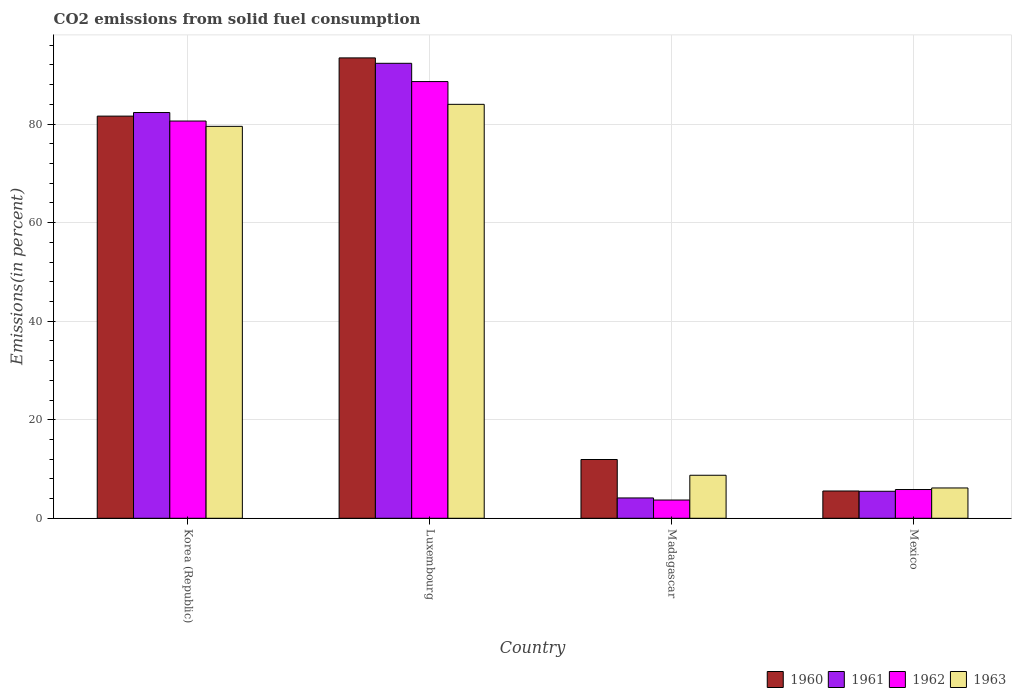How many groups of bars are there?
Provide a short and direct response. 4. How many bars are there on the 2nd tick from the left?
Offer a terse response. 4. What is the label of the 2nd group of bars from the left?
Your answer should be very brief. Luxembourg. In how many cases, is the number of bars for a given country not equal to the number of legend labels?
Your answer should be compact. 0. What is the total CO2 emitted in 1963 in Madagascar?
Offer a very short reply. 8.73. Across all countries, what is the maximum total CO2 emitted in 1962?
Provide a short and direct response. 88.63. Across all countries, what is the minimum total CO2 emitted in 1963?
Make the answer very short. 6.15. In which country was the total CO2 emitted in 1962 maximum?
Provide a short and direct response. Luxembourg. In which country was the total CO2 emitted in 1962 minimum?
Offer a very short reply. Madagascar. What is the total total CO2 emitted in 1960 in the graph?
Keep it short and to the point. 192.53. What is the difference between the total CO2 emitted in 1961 in Korea (Republic) and that in Luxembourg?
Offer a very short reply. -9.99. What is the difference between the total CO2 emitted in 1963 in Madagascar and the total CO2 emitted in 1962 in Korea (Republic)?
Your answer should be very brief. -71.89. What is the average total CO2 emitted in 1961 per country?
Provide a short and direct response. 46.08. What is the difference between the total CO2 emitted of/in 1962 and total CO2 emitted of/in 1961 in Luxembourg?
Give a very brief answer. -3.71. What is the ratio of the total CO2 emitted in 1962 in Luxembourg to that in Mexico?
Offer a very short reply. 15.2. Is the total CO2 emitted in 1963 in Madagascar less than that in Mexico?
Provide a succinct answer. No. Is the difference between the total CO2 emitted in 1962 in Madagascar and Mexico greater than the difference between the total CO2 emitted in 1961 in Madagascar and Mexico?
Offer a very short reply. No. What is the difference between the highest and the second highest total CO2 emitted in 1963?
Keep it short and to the point. -75.29. What is the difference between the highest and the lowest total CO2 emitted in 1960?
Offer a very short reply. 87.9. What does the 2nd bar from the right in Luxembourg represents?
Offer a very short reply. 1962. Are all the bars in the graph horizontal?
Offer a very short reply. No. What is the difference between two consecutive major ticks on the Y-axis?
Provide a succinct answer. 20. Are the values on the major ticks of Y-axis written in scientific E-notation?
Offer a terse response. No. Does the graph contain any zero values?
Your answer should be very brief. No. Does the graph contain grids?
Ensure brevity in your answer.  Yes. Where does the legend appear in the graph?
Provide a short and direct response. Bottom right. How are the legend labels stacked?
Your answer should be compact. Horizontal. What is the title of the graph?
Your answer should be compact. CO2 emissions from solid fuel consumption. Does "1988" appear as one of the legend labels in the graph?
Keep it short and to the point. No. What is the label or title of the X-axis?
Provide a short and direct response. Country. What is the label or title of the Y-axis?
Ensure brevity in your answer.  Emissions(in percent). What is the Emissions(in percent) of 1960 in Korea (Republic)?
Provide a short and direct response. 81.62. What is the Emissions(in percent) of 1961 in Korea (Republic)?
Make the answer very short. 82.35. What is the Emissions(in percent) in 1962 in Korea (Republic)?
Ensure brevity in your answer.  80.62. What is the Emissions(in percent) of 1963 in Korea (Republic)?
Offer a very short reply. 79.55. What is the Emissions(in percent) of 1960 in Luxembourg?
Ensure brevity in your answer.  93.44. What is the Emissions(in percent) of 1961 in Luxembourg?
Your answer should be very brief. 92.34. What is the Emissions(in percent) of 1962 in Luxembourg?
Ensure brevity in your answer.  88.63. What is the Emissions(in percent) in 1963 in Luxembourg?
Your response must be concise. 84.02. What is the Emissions(in percent) in 1960 in Madagascar?
Offer a very short reply. 11.93. What is the Emissions(in percent) in 1961 in Madagascar?
Offer a terse response. 4.12. What is the Emissions(in percent) in 1962 in Madagascar?
Give a very brief answer. 3.7. What is the Emissions(in percent) in 1963 in Madagascar?
Offer a very short reply. 8.73. What is the Emissions(in percent) of 1960 in Mexico?
Provide a succinct answer. 5.54. What is the Emissions(in percent) in 1961 in Mexico?
Keep it short and to the point. 5.48. What is the Emissions(in percent) in 1962 in Mexico?
Your answer should be very brief. 5.83. What is the Emissions(in percent) of 1963 in Mexico?
Provide a succinct answer. 6.15. Across all countries, what is the maximum Emissions(in percent) of 1960?
Your answer should be compact. 93.44. Across all countries, what is the maximum Emissions(in percent) in 1961?
Provide a succinct answer. 92.34. Across all countries, what is the maximum Emissions(in percent) in 1962?
Offer a terse response. 88.63. Across all countries, what is the maximum Emissions(in percent) in 1963?
Your response must be concise. 84.02. Across all countries, what is the minimum Emissions(in percent) in 1960?
Keep it short and to the point. 5.54. Across all countries, what is the minimum Emissions(in percent) in 1961?
Make the answer very short. 4.12. Across all countries, what is the minimum Emissions(in percent) of 1962?
Your answer should be compact. 3.7. Across all countries, what is the minimum Emissions(in percent) in 1963?
Your answer should be very brief. 6.15. What is the total Emissions(in percent) in 1960 in the graph?
Give a very brief answer. 192.53. What is the total Emissions(in percent) of 1961 in the graph?
Give a very brief answer. 184.3. What is the total Emissions(in percent) in 1962 in the graph?
Keep it short and to the point. 178.8. What is the total Emissions(in percent) in 1963 in the graph?
Keep it short and to the point. 178.45. What is the difference between the Emissions(in percent) of 1960 in Korea (Republic) and that in Luxembourg?
Provide a short and direct response. -11.82. What is the difference between the Emissions(in percent) in 1961 in Korea (Republic) and that in Luxembourg?
Ensure brevity in your answer.  -9.99. What is the difference between the Emissions(in percent) in 1962 in Korea (Republic) and that in Luxembourg?
Give a very brief answer. -8.01. What is the difference between the Emissions(in percent) of 1963 in Korea (Republic) and that in Luxembourg?
Your response must be concise. -4.47. What is the difference between the Emissions(in percent) of 1960 in Korea (Republic) and that in Madagascar?
Your answer should be compact. 69.7. What is the difference between the Emissions(in percent) in 1961 in Korea (Republic) and that in Madagascar?
Keep it short and to the point. 78.23. What is the difference between the Emissions(in percent) in 1962 in Korea (Republic) and that in Madagascar?
Your answer should be very brief. 76.92. What is the difference between the Emissions(in percent) of 1963 in Korea (Republic) and that in Madagascar?
Ensure brevity in your answer.  70.82. What is the difference between the Emissions(in percent) of 1960 in Korea (Republic) and that in Mexico?
Your response must be concise. 76.09. What is the difference between the Emissions(in percent) in 1961 in Korea (Republic) and that in Mexico?
Provide a short and direct response. 76.87. What is the difference between the Emissions(in percent) of 1962 in Korea (Republic) and that in Mexico?
Provide a succinct answer. 74.79. What is the difference between the Emissions(in percent) of 1963 in Korea (Republic) and that in Mexico?
Make the answer very short. 73.4. What is the difference between the Emissions(in percent) of 1960 in Luxembourg and that in Madagascar?
Your response must be concise. 81.52. What is the difference between the Emissions(in percent) of 1961 in Luxembourg and that in Madagascar?
Provide a short and direct response. 88.22. What is the difference between the Emissions(in percent) in 1962 in Luxembourg and that in Madagascar?
Your answer should be very brief. 84.93. What is the difference between the Emissions(in percent) of 1963 in Luxembourg and that in Madagascar?
Keep it short and to the point. 75.29. What is the difference between the Emissions(in percent) of 1960 in Luxembourg and that in Mexico?
Ensure brevity in your answer.  87.9. What is the difference between the Emissions(in percent) of 1961 in Luxembourg and that in Mexico?
Your answer should be compact. 86.86. What is the difference between the Emissions(in percent) of 1962 in Luxembourg and that in Mexico?
Your answer should be compact. 82.8. What is the difference between the Emissions(in percent) of 1963 in Luxembourg and that in Mexico?
Your answer should be very brief. 77.87. What is the difference between the Emissions(in percent) of 1960 in Madagascar and that in Mexico?
Keep it short and to the point. 6.39. What is the difference between the Emissions(in percent) of 1961 in Madagascar and that in Mexico?
Provide a short and direct response. -1.36. What is the difference between the Emissions(in percent) of 1962 in Madagascar and that in Mexico?
Provide a succinct answer. -2.13. What is the difference between the Emissions(in percent) in 1963 in Madagascar and that in Mexico?
Your answer should be compact. 2.58. What is the difference between the Emissions(in percent) of 1960 in Korea (Republic) and the Emissions(in percent) of 1961 in Luxembourg?
Ensure brevity in your answer.  -10.72. What is the difference between the Emissions(in percent) in 1960 in Korea (Republic) and the Emissions(in percent) in 1962 in Luxembourg?
Provide a succinct answer. -7.01. What is the difference between the Emissions(in percent) of 1960 in Korea (Republic) and the Emissions(in percent) of 1963 in Luxembourg?
Give a very brief answer. -2.39. What is the difference between the Emissions(in percent) in 1961 in Korea (Republic) and the Emissions(in percent) in 1962 in Luxembourg?
Provide a short and direct response. -6.28. What is the difference between the Emissions(in percent) in 1961 in Korea (Republic) and the Emissions(in percent) in 1963 in Luxembourg?
Your answer should be very brief. -1.66. What is the difference between the Emissions(in percent) in 1962 in Korea (Republic) and the Emissions(in percent) in 1963 in Luxembourg?
Your answer should be very brief. -3.39. What is the difference between the Emissions(in percent) of 1960 in Korea (Republic) and the Emissions(in percent) of 1961 in Madagascar?
Your response must be concise. 77.5. What is the difference between the Emissions(in percent) in 1960 in Korea (Republic) and the Emissions(in percent) in 1962 in Madagascar?
Provide a short and direct response. 77.92. What is the difference between the Emissions(in percent) in 1960 in Korea (Republic) and the Emissions(in percent) in 1963 in Madagascar?
Offer a terse response. 72.89. What is the difference between the Emissions(in percent) in 1961 in Korea (Republic) and the Emissions(in percent) in 1962 in Madagascar?
Your response must be concise. 78.65. What is the difference between the Emissions(in percent) of 1961 in Korea (Republic) and the Emissions(in percent) of 1963 in Madagascar?
Your answer should be very brief. 73.62. What is the difference between the Emissions(in percent) of 1962 in Korea (Republic) and the Emissions(in percent) of 1963 in Madagascar?
Give a very brief answer. 71.89. What is the difference between the Emissions(in percent) in 1960 in Korea (Republic) and the Emissions(in percent) in 1961 in Mexico?
Make the answer very short. 76.14. What is the difference between the Emissions(in percent) in 1960 in Korea (Republic) and the Emissions(in percent) in 1962 in Mexico?
Offer a very short reply. 75.79. What is the difference between the Emissions(in percent) in 1960 in Korea (Republic) and the Emissions(in percent) in 1963 in Mexico?
Your answer should be very brief. 75.47. What is the difference between the Emissions(in percent) of 1961 in Korea (Republic) and the Emissions(in percent) of 1962 in Mexico?
Keep it short and to the point. 76.52. What is the difference between the Emissions(in percent) of 1961 in Korea (Republic) and the Emissions(in percent) of 1963 in Mexico?
Your answer should be very brief. 76.2. What is the difference between the Emissions(in percent) in 1962 in Korea (Republic) and the Emissions(in percent) in 1963 in Mexico?
Ensure brevity in your answer.  74.47. What is the difference between the Emissions(in percent) in 1960 in Luxembourg and the Emissions(in percent) in 1961 in Madagascar?
Provide a short and direct response. 89.32. What is the difference between the Emissions(in percent) in 1960 in Luxembourg and the Emissions(in percent) in 1962 in Madagascar?
Your answer should be compact. 89.74. What is the difference between the Emissions(in percent) of 1960 in Luxembourg and the Emissions(in percent) of 1963 in Madagascar?
Provide a short and direct response. 84.71. What is the difference between the Emissions(in percent) in 1961 in Luxembourg and the Emissions(in percent) in 1962 in Madagascar?
Keep it short and to the point. 88.64. What is the difference between the Emissions(in percent) in 1961 in Luxembourg and the Emissions(in percent) in 1963 in Madagascar?
Provide a short and direct response. 83.61. What is the difference between the Emissions(in percent) in 1962 in Luxembourg and the Emissions(in percent) in 1963 in Madagascar?
Provide a succinct answer. 79.9. What is the difference between the Emissions(in percent) in 1960 in Luxembourg and the Emissions(in percent) in 1961 in Mexico?
Your response must be concise. 87.96. What is the difference between the Emissions(in percent) of 1960 in Luxembourg and the Emissions(in percent) of 1962 in Mexico?
Make the answer very short. 87.61. What is the difference between the Emissions(in percent) of 1960 in Luxembourg and the Emissions(in percent) of 1963 in Mexico?
Keep it short and to the point. 87.29. What is the difference between the Emissions(in percent) of 1961 in Luxembourg and the Emissions(in percent) of 1962 in Mexico?
Make the answer very short. 86.51. What is the difference between the Emissions(in percent) in 1961 in Luxembourg and the Emissions(in percent) in 1963 in Mexico?
Give a very brief answer. 86.19. What is the difference between the Emissions(in percent) of 1962 in Luxembourg and the Emissions(in percent) of 1963 in Mexico?
Offer a very short reply. 82.48. What is the difference between the Emissions(in percent) in 1960 in Madagascar and the Emissions(in percent) in 1961 in Mexico?
Make the answer very short. 6.45. What is the difference between the Emissions(in percent) in 1960 in Madagascar and the Emissions(in percent) in 1962 in Mexico?
Offer a very short reply. 6.09. What is the difference between the Emissions(in percent) in 1960 in Madagascar and the Emissions(in percent) in 1963 in Mexico?
Provide a succinct answer. 5.78. What is the difference between the Emissions(in percent) in 1961 in Madagascar and the Emissions(in percent) in 1962 in Mexico?
Offer a terse response. -1.71. What is the difference between the Emissions(in percent) of 1961 in Madagascar and the Emissions(in percent) of 1963 in Mexico?
Your answer should be very brief. -2.03. What is the difference between the Emissions(in percent) of 1962 in Madagascar and the Emissions(in percent) of 1963 in Mexico?
Offer a very short reply. -2.45. What is the average Emissions(in percent) of 1960 per country?
Provide a succinct answer. 48.13. What is the average Emissions(in percent) of 1961 per country?
Offer a terse response. 46.08. What is the average Emissions(in percent) of 1962 per country?
Your answer should be very brief. 44.7. What is the average Emissions(in percent) of 1963 per country?
Ensure brevity in your answer.  44.61. What is the difference between the Emissions(in percent) of 1960 and Emissions(in percent) of 1961 in Korea (Republic)?
Keep it short and to the point. -0.73. What is the difference between the Emissions(in percent) of 1960 and Emissions(in percent) of 1962 in Korea (Republic)?
Offer a terse response. 1. What is the difference between the Emissions(in percent) of 1960 and Emissions(in percent) of 1963 in Korea (Republic)?
Your answer should be very brief. 2.08. What is the difference between the Emissions(in percent) in 1961 and Emissions(in percent) in 1962 in Korea (Republic)?
Offer a very short reply. 1.73. What is the difference between the Emissions(in percent) of 1961 and Emissions(in percent) of 1963 in Korea (Republic)?
Offer a very short reply. 2.8. What is the difference between the Emissions(in percent) in 1962 and Emissions(in percent) in 1963 in Korea (Republic)?
Your answer should be very brief. 1.08. What is the difference between the Emissions(in percent) in 1960 and Emissions(in percent) in 1961 in Luxembourg?
Your response must be concise. 1.1. What is the difference between the Emissions(in percent) of 1960 and Emissions(in percent) of 1962 in Luxembourg?
Offer a terse response. 4.81. What is the difference between the Emissions(in percent) of 1960 and Emissions(in percent) of 1963 in Luxembourg?
Keep it short and to the point. 9.42. What is the difference between the Emissions(in percent) in 1961 and Emissions(in percent) in 1962 in Luxembourg?
Your answer should be very brief. 3.71. What is the difference between the Emissions(in percent) of 1961 and Emissions(in percent) of 1963 in Luxembourg?
Give a very brief answer. 8.33. What is the difference between the Emissions(in percent) in 1962 and Emissions(in percent) in 1963 in Luxembourg?
Offer a terse response. 4.62. What is the difference between the Emissions(in percent) of 1960 and Emissions(in percent) of 1961 in Madagascar?
Offer a terse response. 7.8. What is the difference between the Emissions(in percent) in 1960 and Emissions(in percent) in 1962 in Madagascar?
Give a very brief answer. 8.22. What is the difference between the Emissions(in percent) of 1960 and Emissions(in percent) of 1963 in Madagascar?
Make the answer very short. 3.2. What is the difference between the Emissions(in percent) in 1961 and Emissions(in percent) in 1962 in Madagascar?
Provide a succinct answer. 0.42. What is the difference between the Emissions(in percent) in 1961 and Emissions(in percent) in 1963 in Madagascar?
Provide a succinct answer. -4.61. What is the difference between the Emissions(in percent) of 1962 and Emissions(in percent) of 1963 in Madagascar?
Offer a terse response. -5.03. What is the difference between the Emissions(in percent) in 1960 and Emissions(in percent) in 1961 in Mexico?
Provide a short and direct response. 0.06. What is the difference between the Emissions(in percent) in 1960 and Emissions(in percent) in 1962 in Mexico?
Your answer should be very brief. -0.3. What is the difference between the Emissions(in percent) in 1960 and Emissions(in percent) in 1963 in Mexico?
Provide a short and direct response. -0.61. What is the difference between the Emissions(in percent) of 1961 and Emissions(in percent) of 1962 in Mexico?
Offer a very short reply. -0.35. What is the difference between the Emissions(in percent) of 1961 and Emissions(in percent) of 1963 in Mexico?
Make the answer very short. -0.67. What is the difference between the Emissions(in percent) in 1962 and Emissions(in percent) in 1963 in Mexico?
Ensure brevity in your answer.  -0.32. What is the ratio of the Emissions(in percent) in 1960 in Korea (Republic) to that in Luxembourg?
Ensure brevity in your answer.  0.87. What is the ratio of the Emissions(in percent) in 1961 in Korea (Republic) to that in Luxembourg?
Give a very brief answer. 0.89. What is the ratio of the Emissions(in percent) in 1962 in Korea (Republic) to that in Luxembourg?
Provide a succinct answer. 0.91. What is the ratio of the Emissions(in percent) of 1963 in Korea (Republic) to that in Luxembourg?
Make the answer very short. 0.95. What is the ratio of the Emissions(in percent) in 1960 in Korea (Republic) to that in Madagascar?
Ensure brevity in your answer.  6.84. What is the ratio of the Emissions(in percent) of 1961 in Korea (Republic) to that in Madagascar?
Make the answer very short. 19.97. What is the ratio of the Emissions(in percent) in 1962 in Korea (Republic) to that in Madagascar?
Offer a very short reply. 21.77. What is the ratio of the Emissions(in percent) of 1963 in Korea (Republic) to that in Madagascar?
Give a very brief answer. 9.11. What is the ratio of the Emissions(in percent) of 1960 in Korea (Republic) to that in Mexico?
Offer a very short reply. 14.74. What is the ratio of the Emissions(in percent) in 1961 in Korea (Republic) to that in Mexico?
Provide a succinct answer. 15.03. What is the ratio of the Emissions(in percent) of 1962 in Korea (Republic) to that in Mexico?
Provide a succinct answer. 13.82. What is the ratio of the Emissions(in percent) in 1963 in Korea (Republic) to that in Mexico?
Make the answer very short. 12.93. What is the ratio of the Emissions(in percent) in 1960 in Luxembourg to that in Madagascar?
Give a very brief answer. 7.83. What is the ratio of the Emissions(in percent) in 1961 in Luxembourg to that in Madagascar?
Your response must be concise. 22.39. What is the ratio of the Emissions(in percent) in 1962 in Luxembourg to that in Madagascar?
Your response must be concise. 23.93. What is the ratio of the Emissions(in percent) of 1963 in Luxembourg to that in Madagascar?
Give a very brief answer. 9.62. What is the ratio of the Emissions(in percent) of 1960 in Luxembourg to that in Mexico?
Make the answer very short. 16.88. What is the ratio of the Emissions(in percent) of 1961 in Luxembourg to that in Mexico?
Provide a short and direct response. 16.85. What is the ratio of the Emissions(in percent) of 1962 in Luxembourg to that in Mexico?
Your answer should be compact. 15.2. What is the ratio of the Emissions(in percent) in 1963 in Luxembourg to that in Mexico?
Give a very brief answer. 13.66. What is the ratio of the Emissions(in percent) in 1960 in Madagascar to that in Mexico?
Make the answer very short. 2.15. What is the ratio of the Emissions(in percent) of 1961 in Madagascar to that in Mexico?
Your response must be concise. 0.75. What is the ratio of the Emissions(in percent) in 1962 in Madagascar to that in Mexico?
Your answer should be compact. 0.64. What is the ratio of the Emissions(in percent) of 1963 in Madagascar to that in Mexico?
Give a very brief answer. 1.42. What is the difference between the highest and the second highest Emissions(in percent) of 1960?
Offer a very short reply. 11.82. What is the difference between the highest and the second highest Emissions(in percent) of 1961?
Make the answer very short. 9.99. What is the difference between the highest and the second highest Emissions(in percent) in 1962?
Make the answer very short. 8.01. What is the difference between the highest and the second highest Emissions(in percent) of 1963?
Provide a succinct answer. 4.47. What is the difference between the highest and the lowest Emissions(in percent) in 1960?
Ensure brevity in your answer.  87.9. What is the difference between the highest and the lowest Emissions(in percent) of 1961?
Offer a very short reply. 88.22. What is the difference between the highest and the lowest Emissions(in percent) of 1962?
Your answer should be very brief. 84.93. What is the difference between the highest and the lowest Emissions(in percent) of 1963?
Provide a succinct answer. 77.87. 